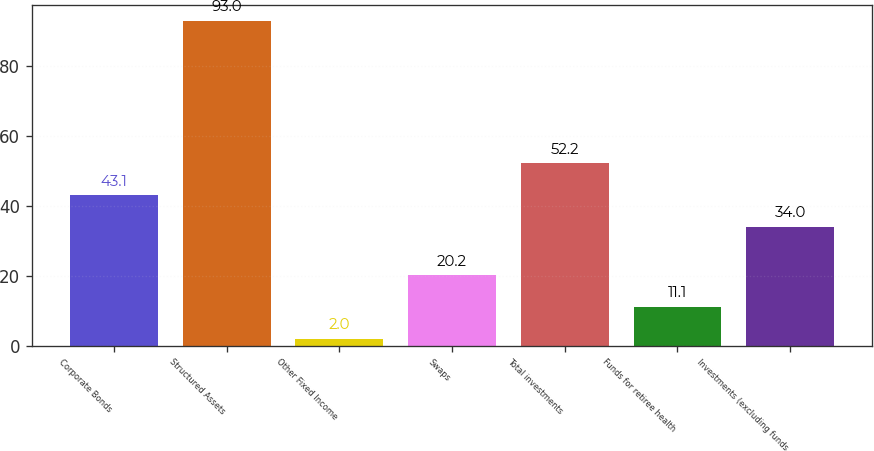<chart> <loc_0><loc_0><loc_500><loc_500><bar_chart><fcel>Corporate Bonds<fcel>Structured Assets<fcel>Other Fixed Income<fcel>Swaps<fcel>Total investments<fcel>Funds for retiree health<fcel>Investments (excluding funds<nl><fcel>43.1<fcel>93<fcel>2<fcel>20.2<fcel>52.2<fcel>11.1<fcel>34<nl></chart> 